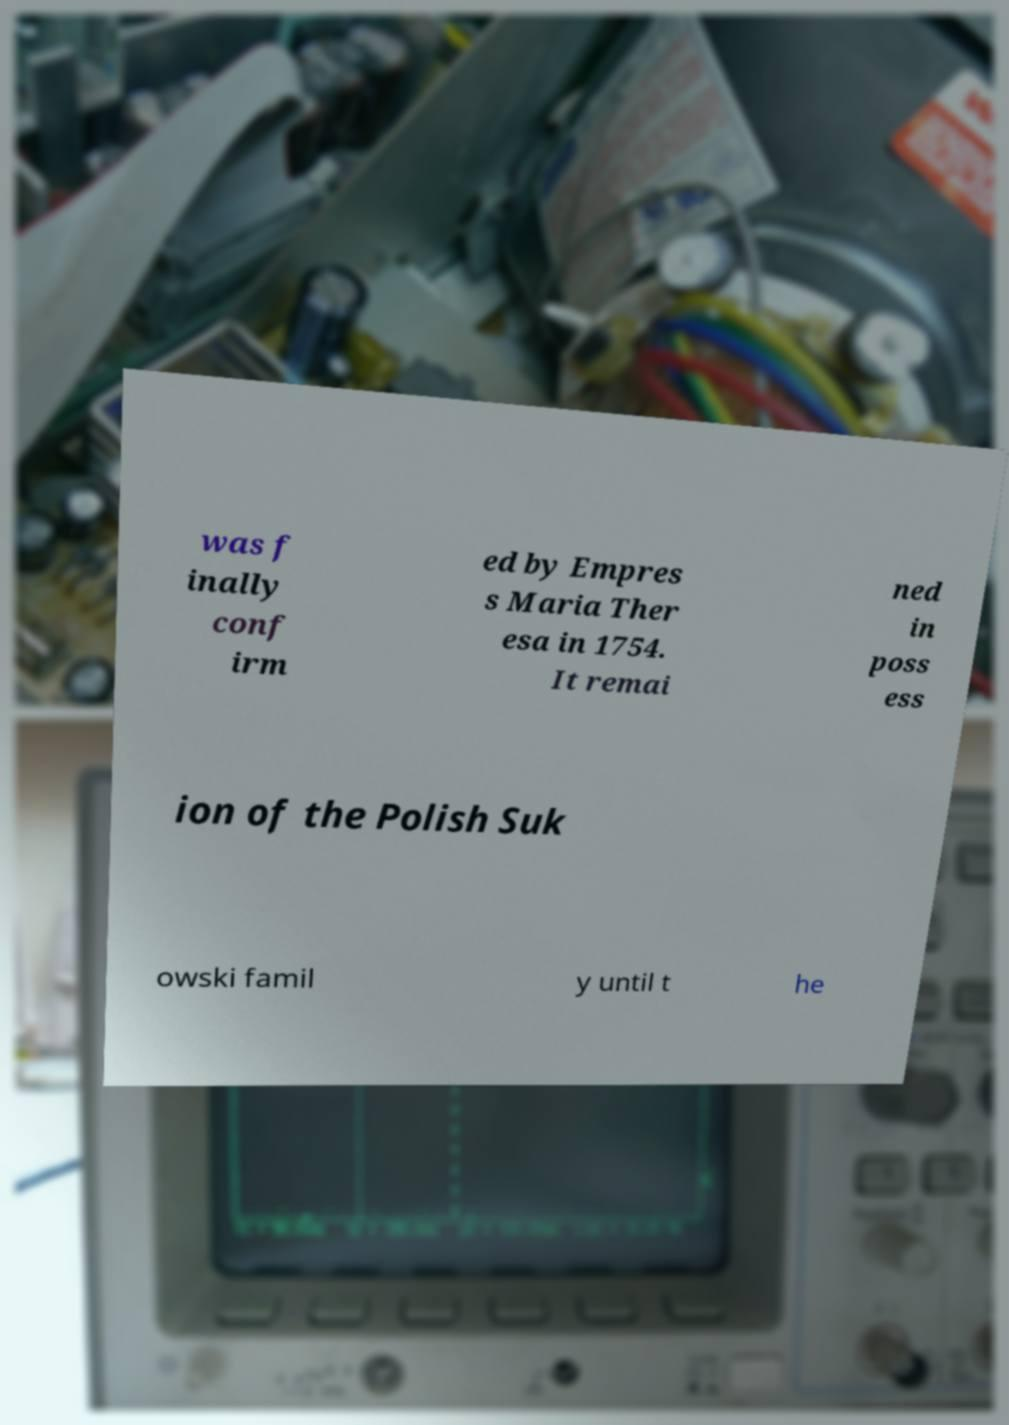What messages or text are displayed in this image? I need them in a readable, typed format. was f inally conf irm ed by Empres s Maria Ther esa in 1754. It remai ned in poss ess ion of the Polish Suk owski famil y until t he 